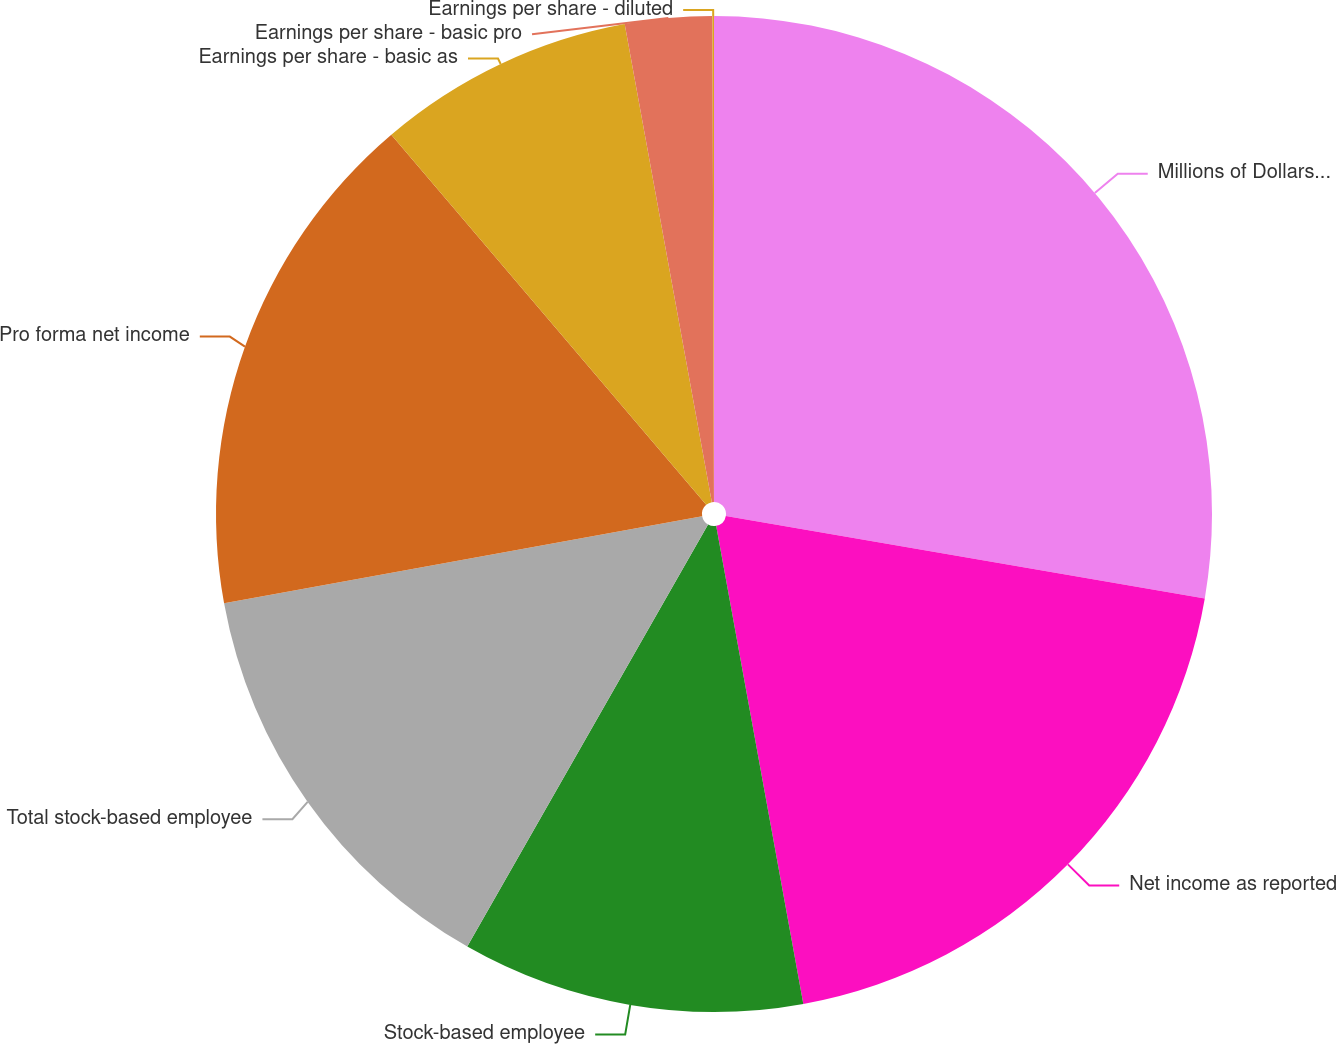<chart> <loc_0><loc_0><loc_500><loc_500><pie_chart><fcel>Millions of Dollars Except Per<fcel>Net income as reported<fcel>Stock-based employee<fcel>Total stock-based employee<fcel>Pro forma net income<fcel>Earnings per share - basic as<fcel>Earnings per share - basic pro<fcel>Earnings per share - diluted<nl><fcel>27.71%<fcel>19.42%<fcel>11.12%<fcel>13.88%<fcel>16.65%<fcel>8.35%<fcel>2.82%<fcel>0.05%<nl></chart> 